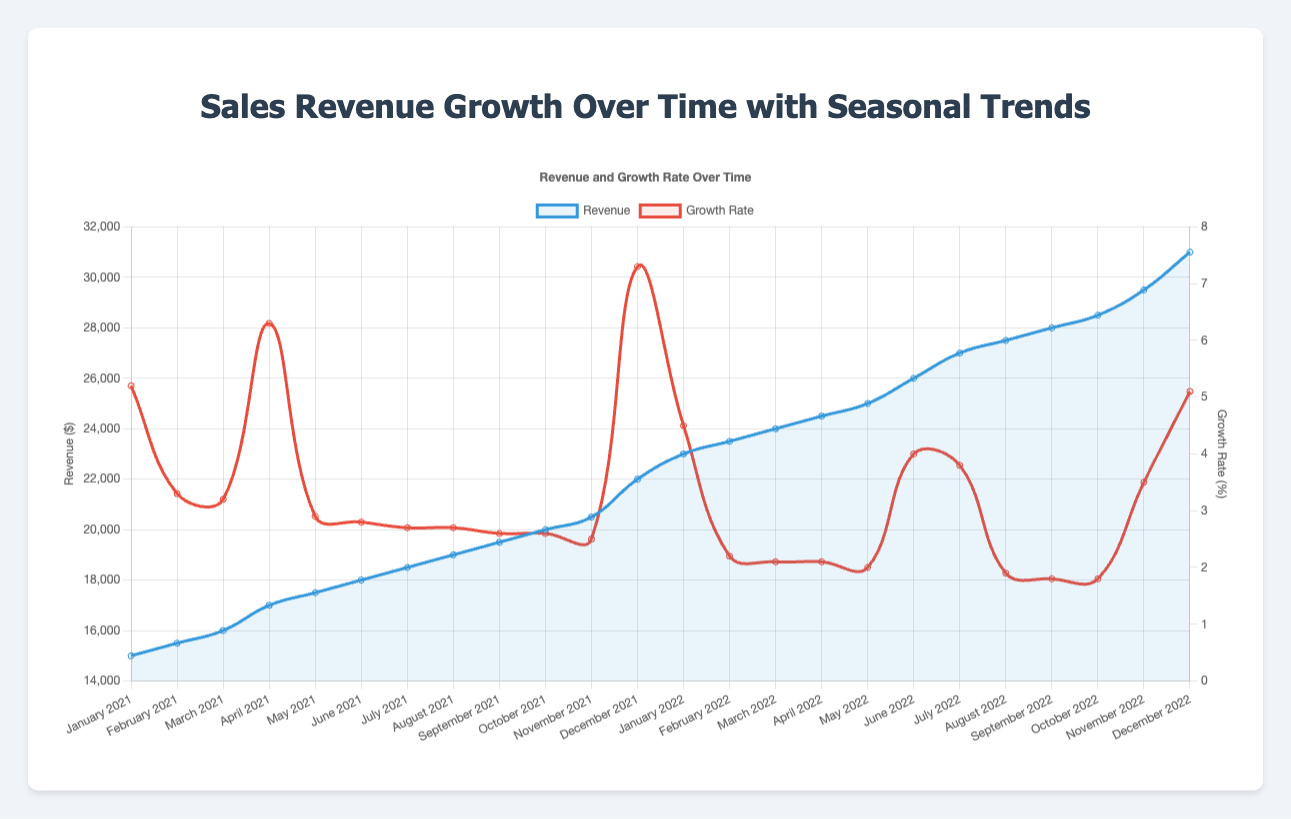What's the month with the highest revenue in 2021? To find the month with the highest revenue in 2021, look at the data points for each month in 2021 on the chart. December 2021 has the highest revenue of $22,000.
Answer: December What is the difference in revenue between January 2021 and January 2022? To find the difference, identify the revenues for January 2021 ($15,000) and January 2022 ($23,000). The difference is $23,000 - $15,000 = $8,000.
Answer: $8,000 Which month in 2022 had the lowest growth rate, and what was it? Look at the growth rates for each month in 2022 on the growth rate line. The lowest growth rate in 2022 is in September, which is 1.8%.
Answer: September, 1.8% How does the revenue trend differ from the growth rate trend in April 2021? Observe both the revenue and growth rate lines for April 2021. The revenue increases from March 2021 to April 2021, while the growth rate also significantly increases to 6.3%. Both trends show an upward movement.
Answer: Both trends increased Suppose you want to calculate the average revenue for the first quarter (January to March) of 2021 and 2022, how would you do it and what is the result? Calculate the average revenue for Q1 2021: (15000 + 15500 + 16000) / 3 = 15,500. For Q1 2022: (23000 + 23500 + 24000) / 3 = 23,167. The Q1 average revenues are 15,500 and 23,167.
Answer: $15,500 and $23,167 How does December 2022's revenue compare to December 2021's revenue? Compare the revenues for December 2022 and December 2021 from the chart. December 2022’s revenue ($31,000) is higher than December 2021’s revenue ($22,000).
Answer: December 2022 had higher revenue In which months did the seasonal trend shift from low to medium in 2021? Identify months labeled with a low and then medium seasonal trend. From January (low) to February (medium), and from September (low) to November (medium).
Answer: February and November Which month saw the highest growth rate in 2021, and what was it? Locate the month with the highest point on the growth rate line for 2021. December 2021 had the highest growth rate of 7.3%.
Answer: December, 7.3% What is the change in revenue from April to June in 2022? Find the April 2022 revenue ($24,500) and June 2022 revenue ($26,000) and calculate the difference: $26,000 - $24,500 = $1,500.
Answer: $1,500 